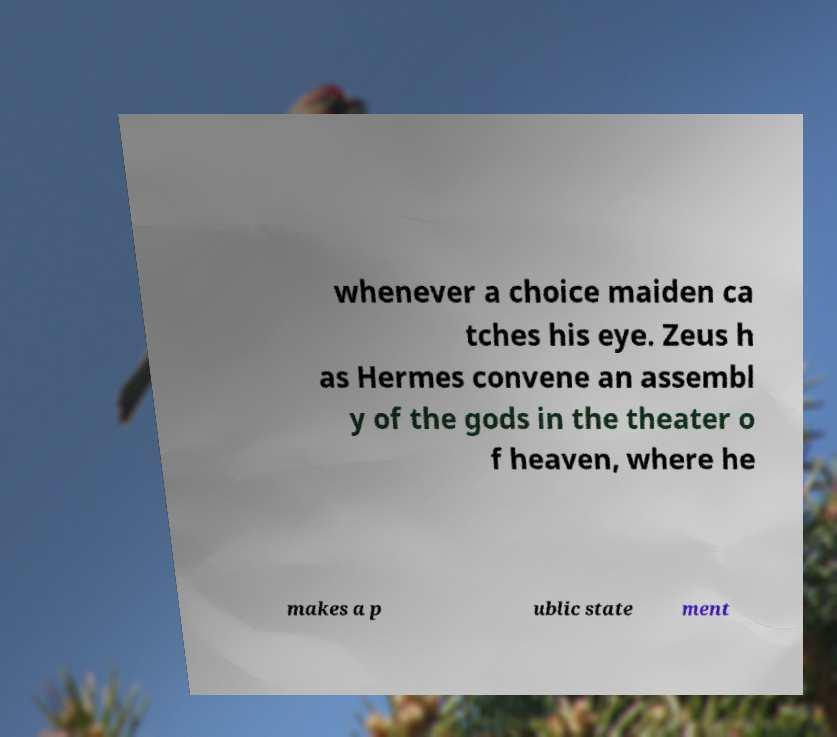Can you read and provide the text displayed in the image?This photo seems to have some interesting text. Can you extract and type it out for me? whenever a choice maiden ca tches his eye. Zeus h as Hermes convene an assembl y of the gods in the theater o f heaven, where he makes a p ublic state ment 